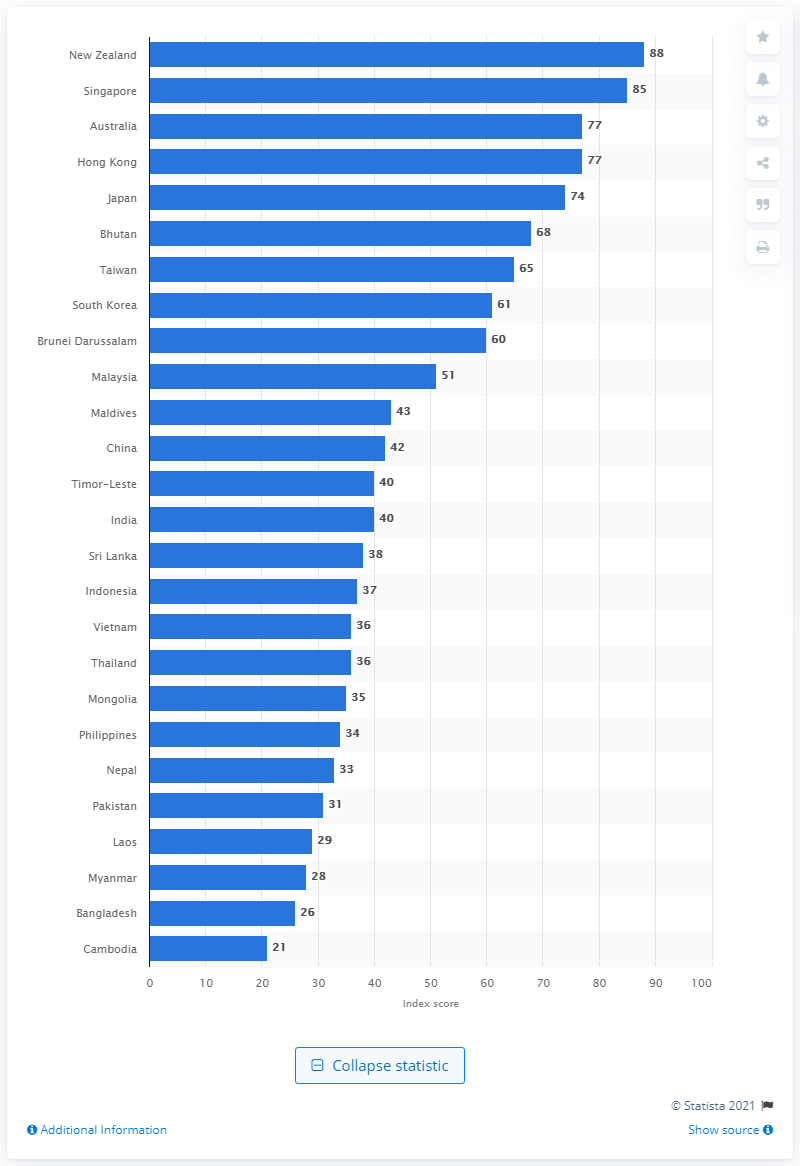Outline some significant characteristics in this image. New Zealand was perceived as the least corrupt country in the Asia Pacific region in 2020. In 2020, New Zealand's corruption index score was 88. In 2020, Cambodia's corruption index score was 21, indicating a moderate level of corruption in the country. 